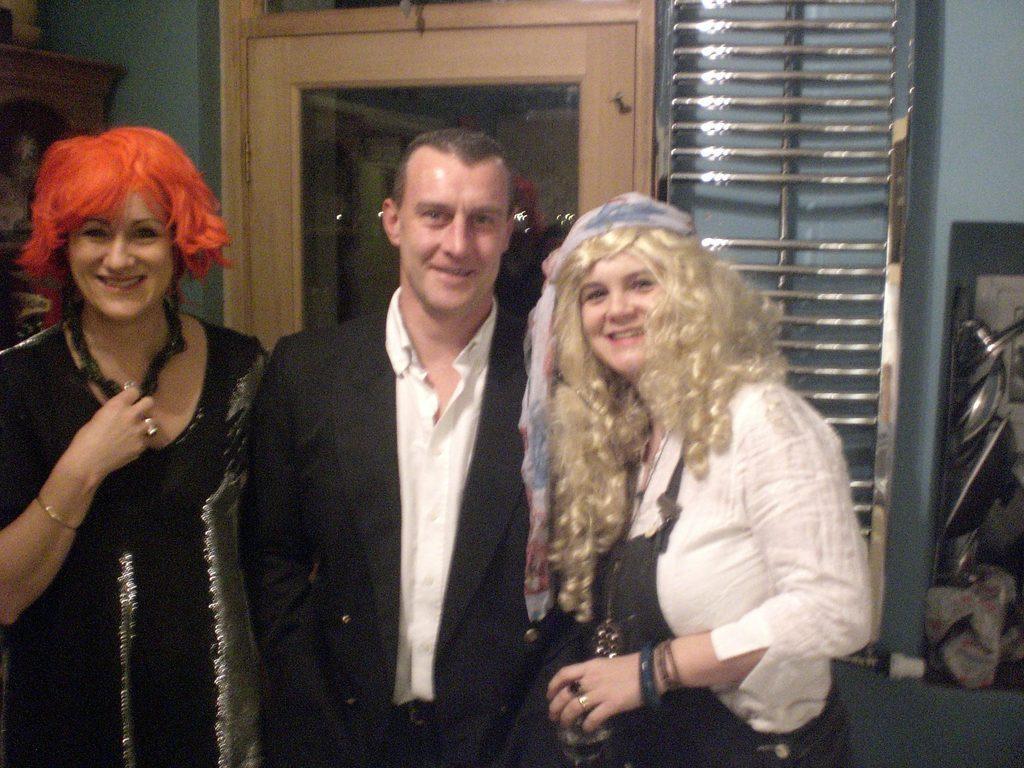Can you describe this image briefly? In this picture we can see few people, they are smiling, behind to them we can see few metal rods and a door. 